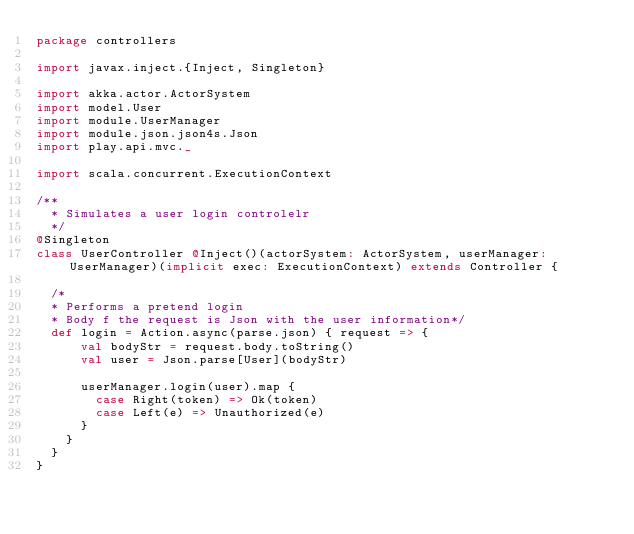<code> <loc_0><loc_0><loc_500><loc_500><_Scala_>package controllers

import javax.inject.{Inject, Singleton}

import akka.actor.ActorSystem
import model.User
import module.UserManager
import module.json.json4s.Json
import play.api.mvc._

import scala.concurrent.ExecutionContext

/**
  * Simulates a user login controlelr
  */
@Singleton
class UserController @Inject()(actorSystem: ActorSystem, userManager:UserManager)(implicit exec: ExecutionContext) extends Controller {

  /*
  * Performs a pretend login
  * Body f the request is Json with the user information*/
  def login = Action.async(parse.json) { request => {
      val bodyStr = request.body.toString()
      val user = Json.parse[User](bodyStr)

      userManager.login(user).map {
        case Right(token) => Ok(token)
        case Left(e) => Unauthorized(e)
      }
    }
  }
}
</code> 